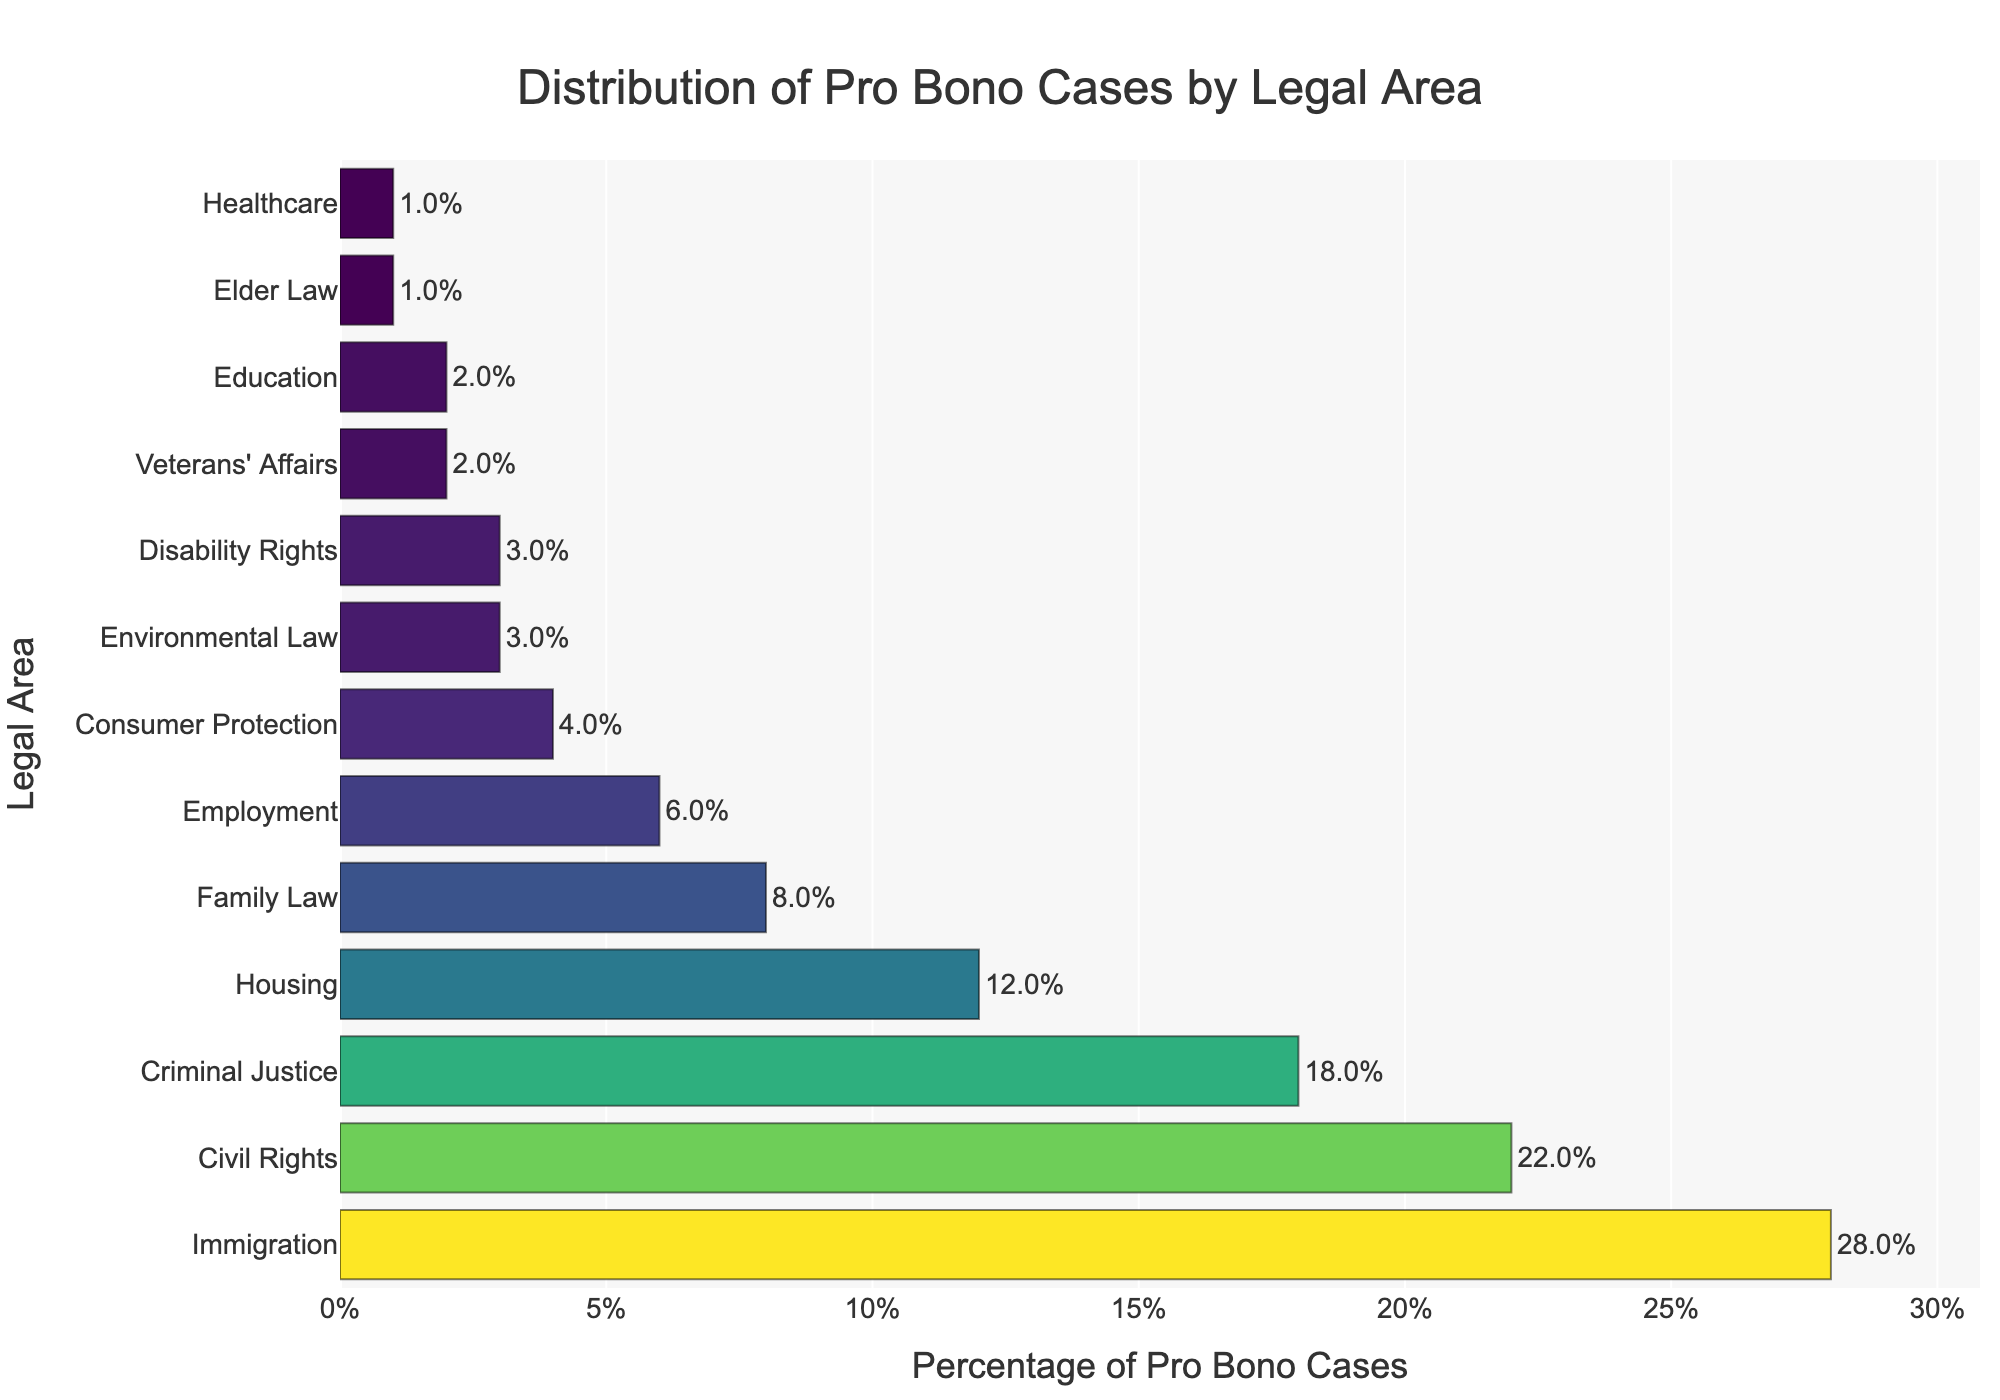Which legal area has the highest percentage of pro bono cases? By looking at the bar with the greatest length, we see that Immigration has the highest percentage of 28%.
Answer: Immigration What is the combined percentage of pro bono cases for Housing, Family Law, and Employment? The percentages are Housing: 12%, Family Law: 8%, and Employment: 6%. Adding them together: 12 + 8 + 6 = 26%.
Answer: 26% Which legal area has a higher percentage of pro bono cases: Criminal Justice or Civil Rights? Compare the lengths of the bars for Criminal Justice and Civil Rights. Civil Rights (22%) is greater than Criminal Justice (18%).
Answer: Civil Rights How much more significant is the percentage of Immigration pro bono cases compared to Environmental Law? Immigration is 28% and Environmental Law is 3%. Subtracting these gives: 28 - 3 = 25%.
Answer: 25% What is the average percentage of pro bono cases for the top three legal areas? The top three areas are Immigration (28%), Civil Rights (22%), and Criminal Justice (18%). Calculating the average: (28 + 22 + 18) / 3 = 22.67%.
Answer: 22.67% Which legal area has the lowest percentage of pro bono cases, and what is that percentage? The bar with the shortest length corresponds to Elder Law and Healthcare, each with 1%.
Answer: Elder Law and Healthcare, 1% Compare the total percentage of pro bono cases between the bottom five legal areas and Immigration. The bottom five legal areas are Environmental Law (3%), Disability Rights (3%), Veterans' Affairs (2%), Education (2%), Elder Law & Healthcare (1% each). Summing these: 3 + 3 + 2 + 2 + 1 + 1 = 12%. Immigration alone is 28%, which is greater.
Answer: Immigration: 28%, Bottom five total: 12% By how much do Civil Rights pro bono cases exceed Disability Rights pro bono cases? Civil Rights is 22% and Disability Rights is 3%. Subtracting these gives: 22 - 3 = 19%.
Answer: 19% What is the percentage difference between the top and bottom legal areas in terms of pro bono cases? The top is Immigration at 28%, and the bottom is Elder Law and Healthcare at 1% each. Subtracting these gives: 28 - 1 = 27%.
Answer: 27% What percentage of pro bono cases are related to consumer issues (Consumer Protection and Employment combined)? Consumer Protection is 4% and Employment is 6%. Adding these gives: 4 + 6 = 10%.
Answer: 10% 